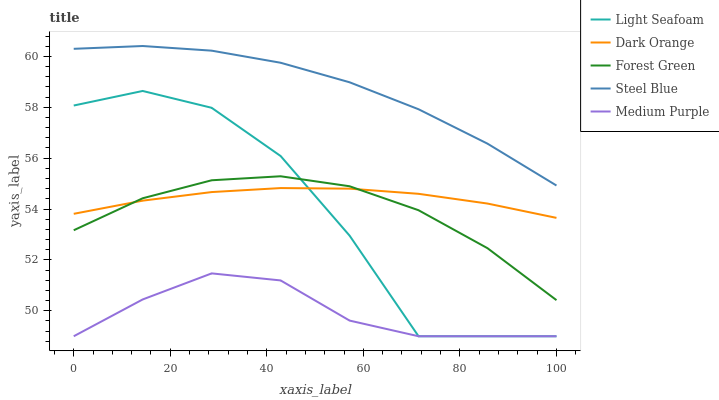Does Medium Purple have the minimum area under the curve?
Answer yes or no. Yes. Does Steel Blue have the maximum area under the curve?
Answer yes or no. Yes. Does Dark Orange have the minimum area under the curve?
Answer yes or no. No. Does Dark Orange have the maximum area under the curve?
Answer yes or no. No. Is Dark Orange the smoothest?
Answer yes or no. Yes. Is Light Seafoam the roughest?
Answer yes or no. Yes. Is Forest Green the smoothest?
Answer yes or no. No. Is Forest Green the roughest?
Answer yes or no. No. Does Medium Purple have the lowest value?
Answer yes or no. Yes. Does Dark Orange have the lowest value?
Answer yes or no. No. Does Steel Blue have the highest value?
Answer yes or no. Yes. Does Dark Orange have the highest value?
Answer yes or no. No. Is Dark Orange less than Steel Blue?
Answer yes or no. Yes. Is Forest Green greater than Medium Purple?
Answer yes or no. Yes. Does Dark Orange intersect Forest Green?
Answer yes or no. Yes. Is Dark Orange less than Forest Green?
Answer yes or no. No. Is Dark Orange greater than Forest Green?
Answer yes or no. No. Does Dark Orange intersect Steel Blue?
Answer yes or no. No. 